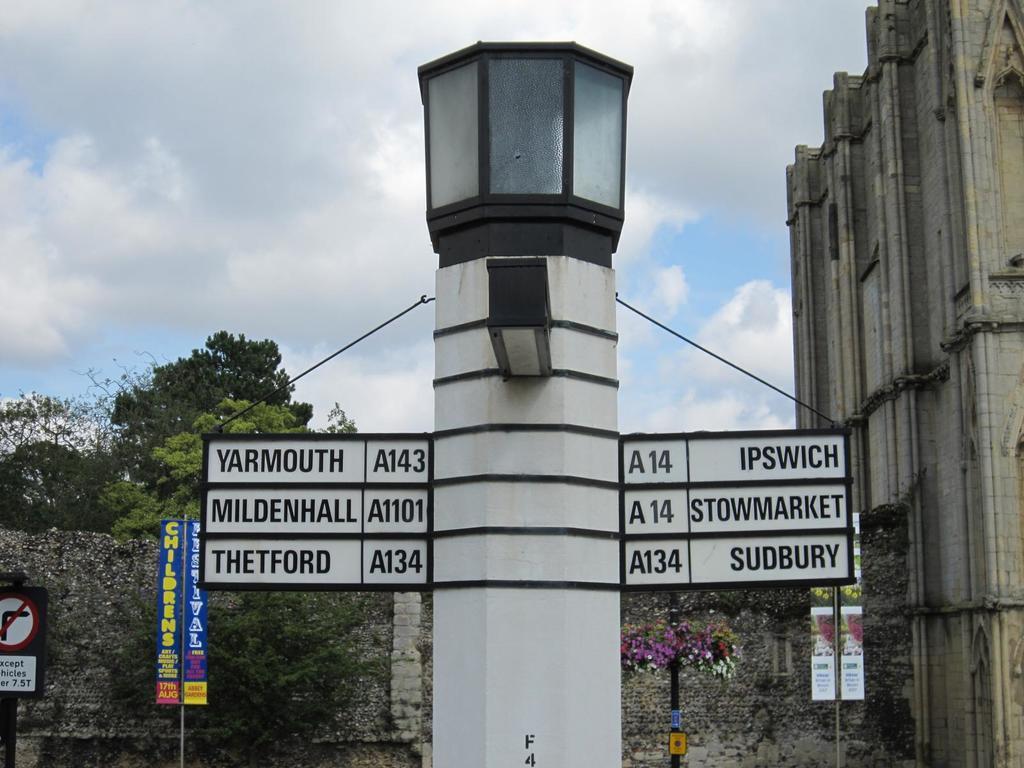Could you give a brief overview of what you see in this image? In the foreground of this image, there is a signage pole. In the background, there is a building, wall, poles, posters, plants, sign board and few trees. On the top, there is the sky and the cloud. 